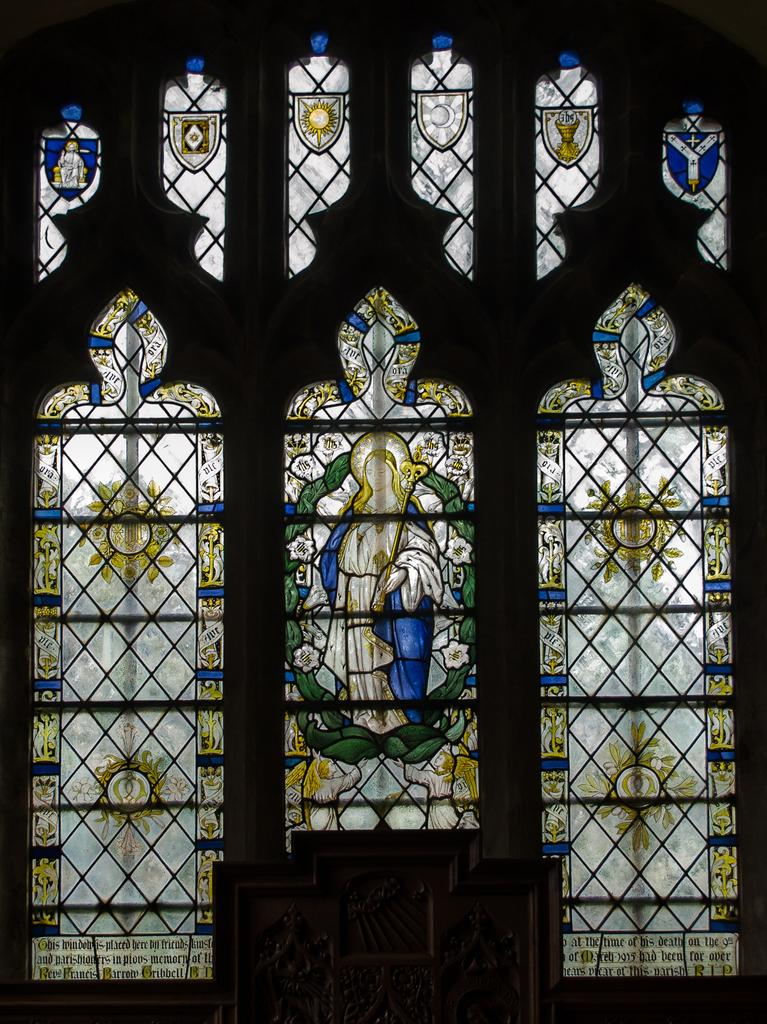What can be seen in the image that provides a view of the outside? There is a window in the image that provides a view of the outside. What is on the window? There is some art on the window. What is located at the bottom of the image? There are objects at the bottom of the image. What type of butter is being used in the meeting depicted in the image? There is no meeting or butter present in the image. 